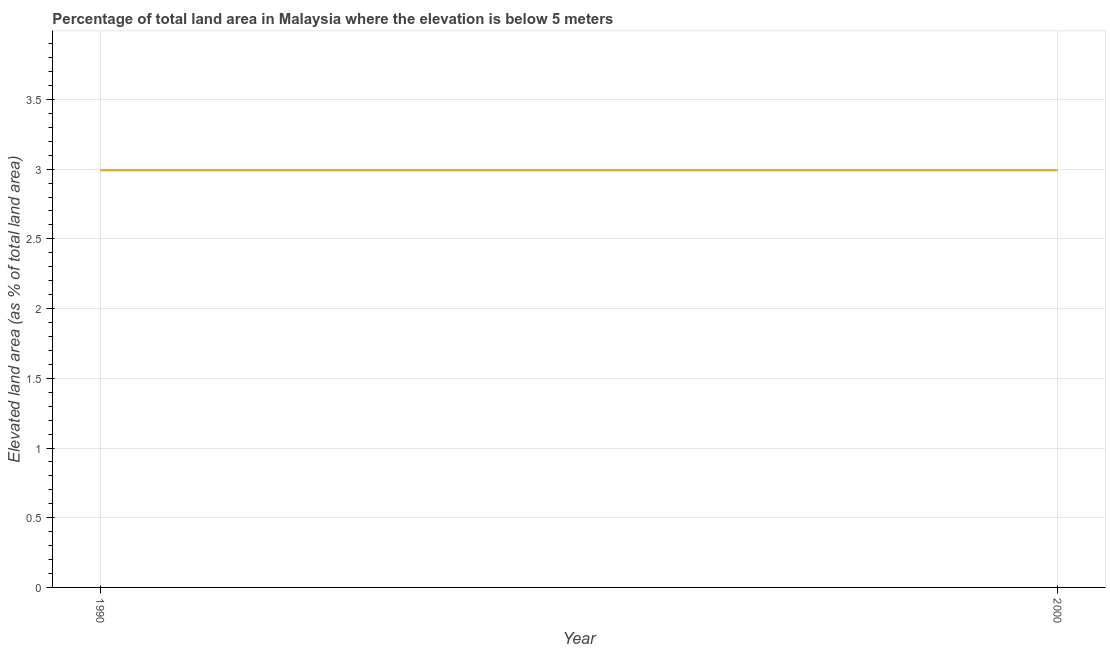What is the total elevated land area in 1990?
Ensure brevity in your answer.  2.99. Across all years, what is the maximum total elevated land area?
Your answer should be very brief. 2.99. Across all years, what is the minimum total elevated land area?
Make the answer very short. 2.99. In which year was the total elevated land area maximum?
Your answer should be compact. 1990. In which year was the total elevated land area minimum?
Provide a succinct answer. 1990. What is the sum of the total elevated land area?
Provide a succinct answer. 5.98. What is the difference between the total elevated land area in 1990 and 2000?
Provide a short and direct response. 0. What is the average total elevated land area per year?
Your response must be concise. 2.99. What is the median total elevated land area?
Your response must be concise. 2.99. In how many years, is the total elevated land area greater than 3.5 %?
Offer a terse response. 0. Do a majority of the years between 1990 and 2000 (inclusive) have total elevated land area greater than 3.8 %?
Your answer should be very brief. No. What is the ratio of the total elevated land area in 1990 to that in 2000?
Keep it short and to the point. 1. Is the total elevated land area in 1990 less than that in 2000?
Your response must be concise. No. In how many years, is the total elevated land area greater than the average total elevated land area taken over all years?
Keep it short and to the point. 0. Does the graph contain grids?
Ensure brevity in your answer.  Yes. What is the title of the graph?
Ensure brevity in your answer.  Percentage of total land area in Malaysia where the elevation is below 5 meters. What is the label or title of the X-axis?
Your answer should be compact. Year. What is the label or title of the Y-axis?
Give a very brief answer. Elevated land area (as % of total land area). What is the Elevated land area (as % of total land area) in 1990?
Provide a short and direct response. 2.99. What is the Elevated land area (as % of total land area) of 2000?
Ensure brevity in your answer.  2.99. What is the difference between the Elevated land area (as % of total land area) in 1990 and 2000?
Ensure brevity in your answer.  0. 